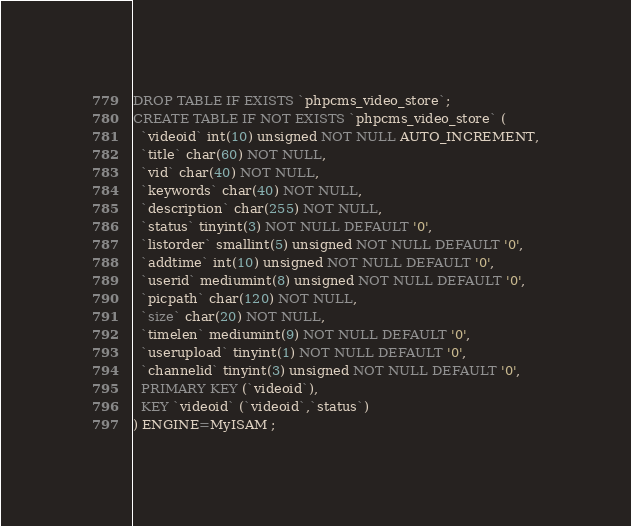<code> <loc_0><loc_0><loc_500><loc_500><_SQL_>DROP TABLE IF EXISTS `phpcms_video_store`;
CREATE TABLE IF NOT EXISTS `phpcms_video_store` (
  `videoid` int(10) unsigned NOT NULL AUTO_INCREMENT,
  `title` char(60) NOT NULL,
  `vid` char(40) NOT NULL,
  `keywords` char(40) NOT NULL,
  `description` char(255) NOT NULL,
  `status` tinyint(3) NOT NULL DEFAULT '0',
  `listorder` smallint(5) unsigned NOT NULL DEFAULT '0',
  `addtime` int(10) unsigned NOT NULL DEFAULT '0',
  `userid` mediumint(8) unsigned NOT NULL DEFAULT '0',
  `picpath` char(120) NOT NULL,
  `size` char(20) NOT NULL,
  `timelen` mediumint(9) NOT NULL DEFAULT '0',
  `userupload` tinyint(1) NOT NULL DEFAULT '0',
  `channelid` tinyint(3) unsigned NOT NULL DEFAULT '0',
  PRIMARY KEY (`videoid`),
  KEY `videoid` (`videoid`,`status`)
) ENGINE=MyISAM ;</code> 